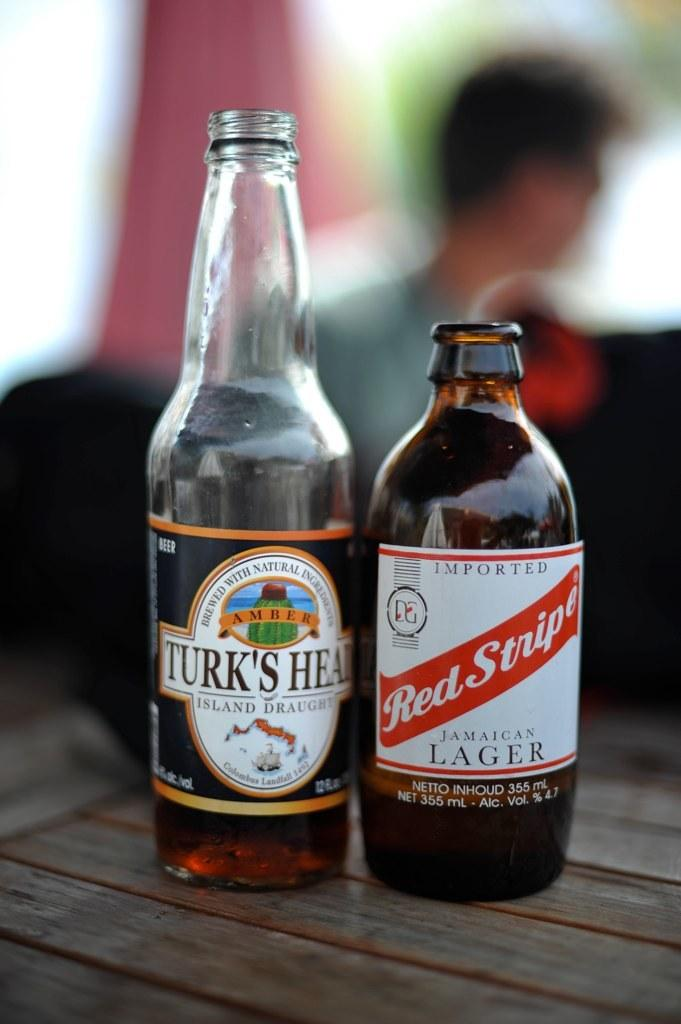<image>
Relay a brief, clear account of the picture shown. Tall bottle of Turk's Head beer next to a bottle of Red Stripe. 